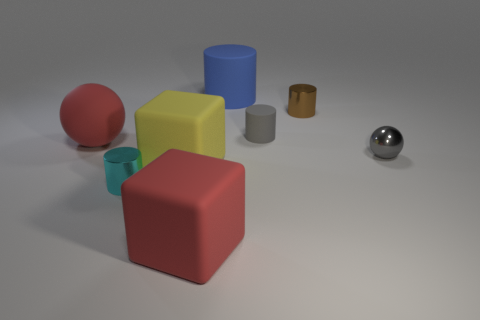What shape is the gray thing right of the tiny matte thing?
Your answer should be very brief. Sphere. What is the cylinder that is to the left of the matte cylinder that is behind the gray cylinder made of?
Make the answer very short. Metal. Are there more large red things that are behind the yellow cube than tiny metallic objects?
Offer a terse response. No. What number of other things are the same color as the small matte cylinder?
Your answer should be compact. 1. There is a red matte thing that is the same size as the matte sphere; what shape is it?
Ensure brevity in your answer.  Cube. There is a red matte thing that is behind the red object right of the large red rubber ball; what number of large matte blocks are behind it?
Your answer should be compact. 0. What number of metal objects are either yellow objects or red objects?
Your response must be concise. 0. The big matte object that is both behind the cyan cylinder and in front of the small gray sphere is what color?
Provide a succinct answer. Yellow. There is a red object that is behind the red rubber block; does it have the same size as the tiny gray shiny sphere?
Your answer should be compact. No. What number of objects are small metal cylinders to the right of the large blue matte cylinder or large blue rubber things?
Provide a succinct answer. 2. 